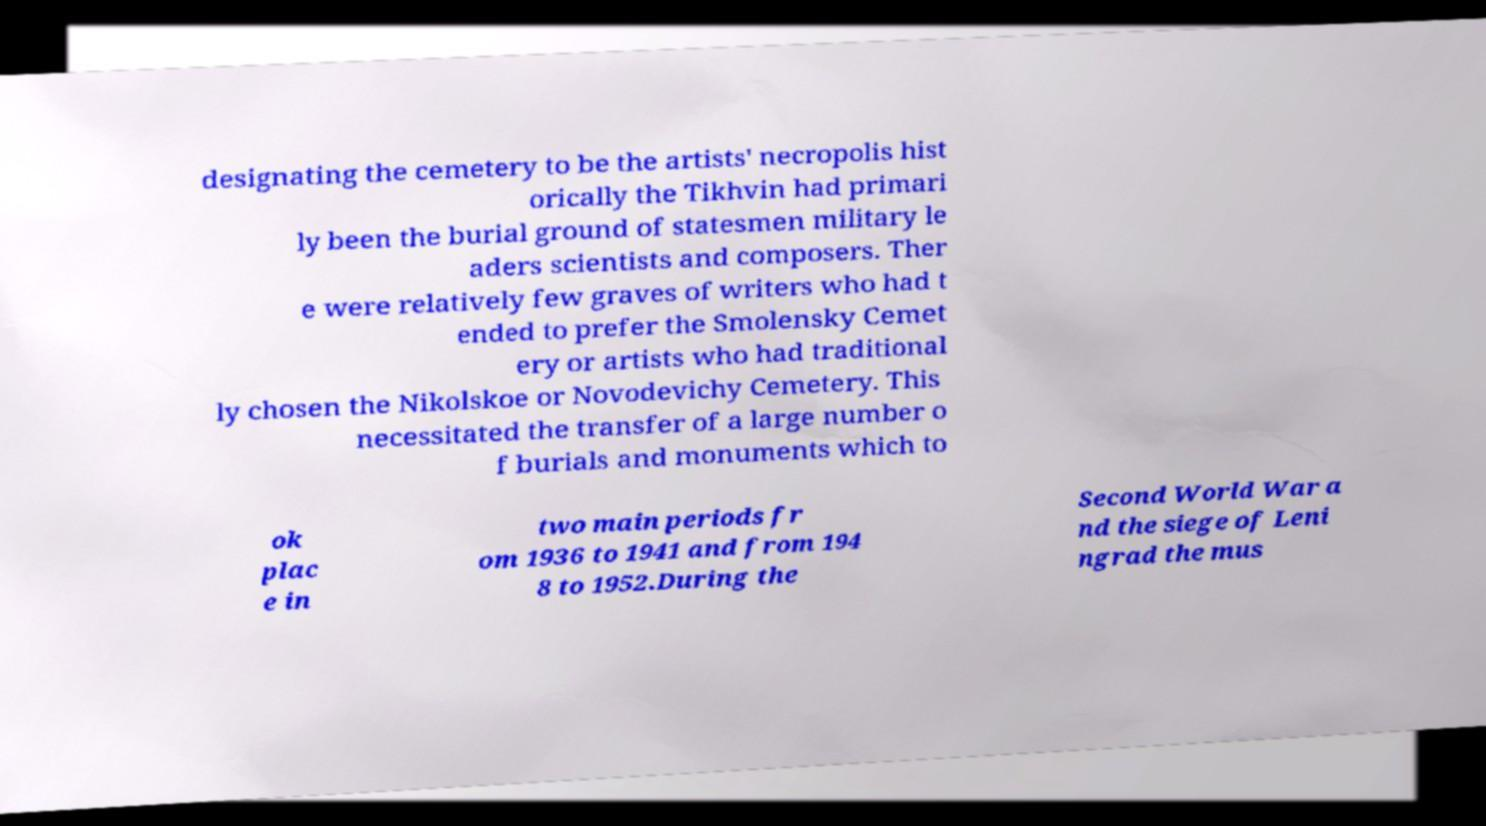I need the written content from this picture converted into text. Can you do that? designating the cemetery to be the artists' necropolis hist orically the Tikhvin had primari ly been the burial ground of statesmen military le aders scientists and composers. Ther e were relatively few graves of writers who had t ended to prefer the Smolensky Cemet ery or artists who had traditional ly chosen the Nikolskoe or Novodevichy Cemetery. This necessitated the transfer of a large number o f burials and monuments which to ok plac e in two main periods fr om 1936 to 1941 and from 194 8 to 1952.During the Second World War a nd the siege of Leni ngrad the mus 